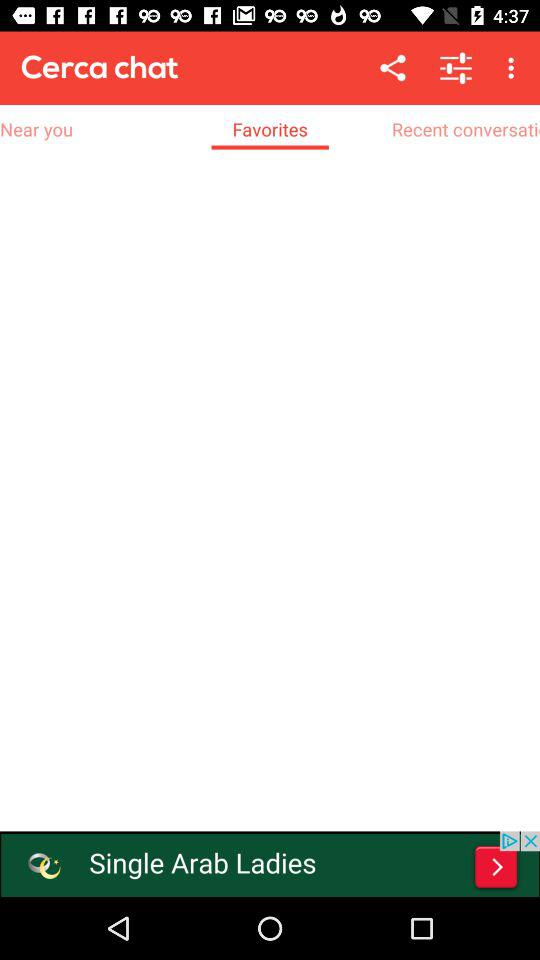When was the most recent conversation posted?
When the provided information is insufficient, respond with <no answer>. <no answer> 